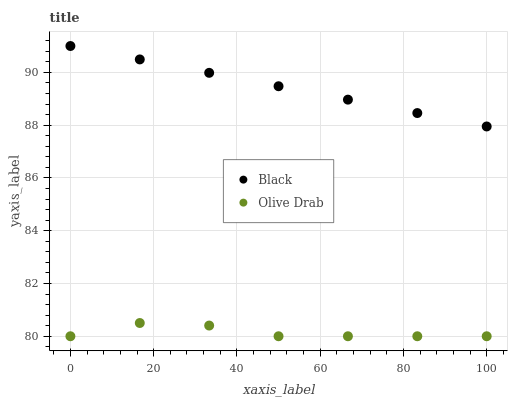Does Olive Drab have the minimum area under the curve?
Answer yes or no. Yes. Does Black have the maximum area under the curve?
Answer yes or no. Yes. Does Olive Drab have the maximum area under the curve?
Answer yes or no. No. Is Black the smoothest?
Answer yes or no. Yes. Is Olive Drab the roughest?
Answer yes or no. Yes. Is Olive Drab the smoothest?
Answer yes or no. No. Does Olive Drab have the lowest value?
Answer yes or no. Yes. Does Black have the highest value?
Answer yes or no. Yes. Does Olive Drab have the highest value?
Answer yes or no. No. Is Olive Drab less than Black?
Answer yes or no. Yes. Is Black greater than Olive Drab?
Answer yes or no. Yes. Does Olive Drab intersect Black?
Answer yes or no. No. 